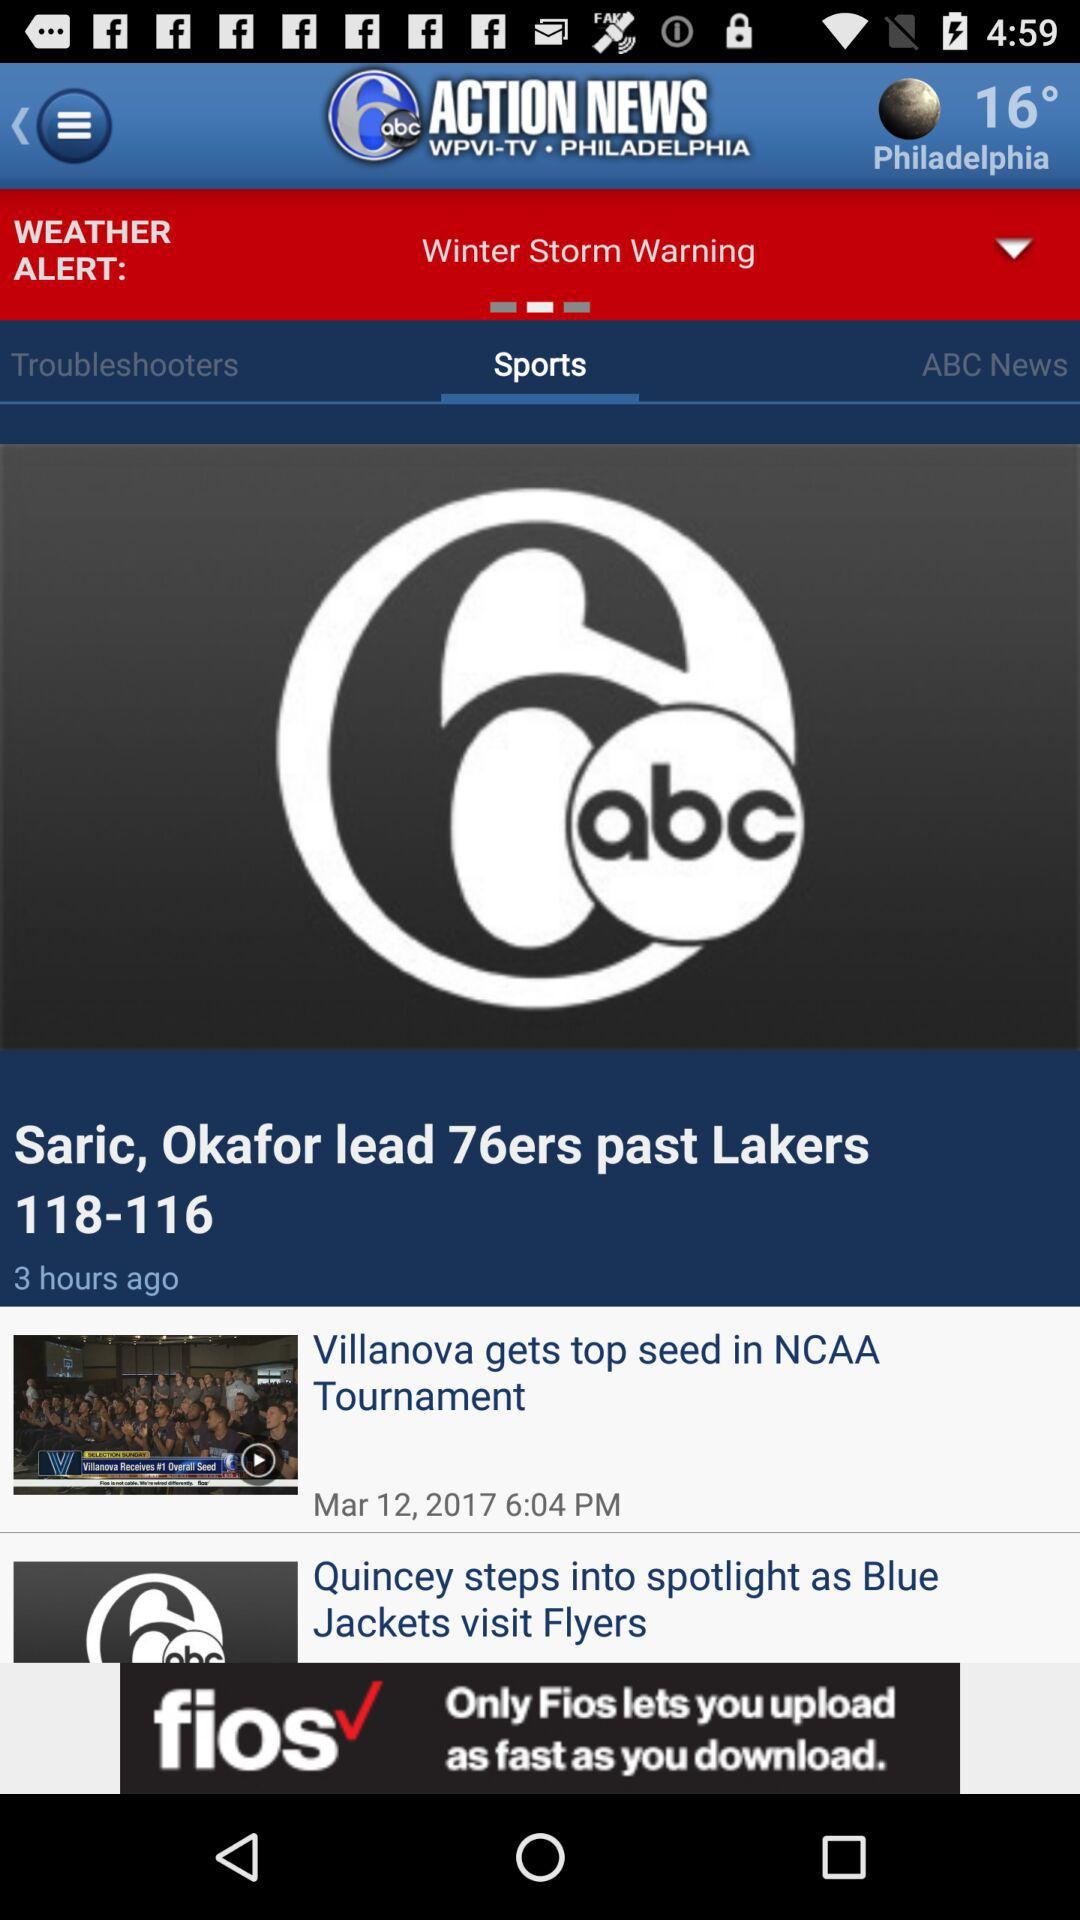Which tab am I on? You are on the "Sports" tab. 